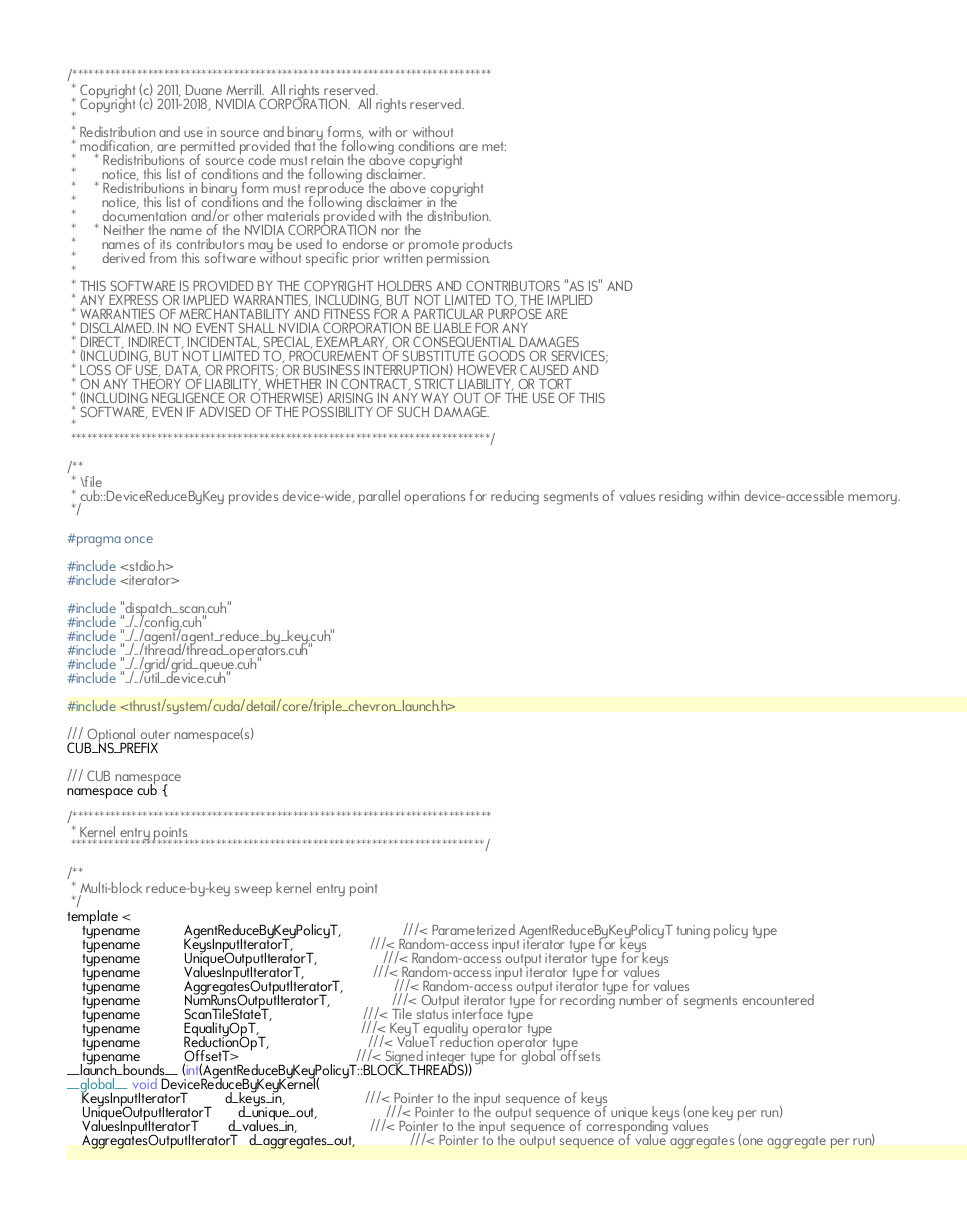Convert code to text. <code><loc_0><loc_0><loc_500><loc_500><_Cuda_>
/******************************************************************************
 * Copyright (c) 2011, Duane Merrill.  All rights reserved.
 * Copyright (c) 2011-2018, NVIDIA CORPORATION.  All rights reserved.
 *
 * Redistribution and use in source and binary forms, with or without
 * modification, are permitted provided that the following conditions are met:
 *     * Redistributions of source code must retain the above copyright
 *       notice, this list of conditions and the following disclaimer.
 *     * Redistributions in binary form must reproduce the above copyright
 *       notice, this list of conditions and the following disclaimer in the
 *       documentation and/or other materials provided with the distribution.
 *     * Neither the name of the NVIDIA CORPORATION nor the
 *       names of its contributors may be used to endorse or promote products
 *       derived from this software without specific prior written permission.
 *
 * THIS SOFTWARE IS PROVIDED BY THE COPYRIGHT HOLDERS AND CONTRIBUTORS "AS IS" AND
 * ANY EXPRESS OR IMPLIED WARRANTIES, INCLUDING, BUT NOT LIMITED TO, THE IMPLIED
 * WARRANTIES OF MERCHANTABILITY AND FITNESS FOR A PARTICULAR PURPOSE ARE
 * DISCLAIMED. IN NO EVENT SHALL NVIDIA CORPORATION BE LIABLE FOR ANY
 * DIRECT, INDIRECT, INCIDENTAL, SPECIAL, EXEMPLARY, OR CONSEQUENTIAL DAMAGES
 * (INCLUDING, BUT NOT LIMITED TO, PROCUREMENT OF SUBSTITUTE GOODS OR SERVICES;
 * LOSS OF USE, DATA, OR PROFITS; OR BUSINESS INTERRUPTION) HOWEVER CAUSED AND
 * ON ANY THEORY OF LIABILITY, WHETHER IN CONTRACT, STRICT LIABILITY, OR TORT
 * (INCLUDING NEGLIGENCE OR OTHERWISE) ARISING IN ANY WAY OUT OF THE USE OF THIS
 * SOFTWARE, EVEN IF ADVISED OF THE POSSIBILITY OF SUCH DAMAGE.
 *
 ******************************************************************************/

/**
 * \file
 * cub::DeviceReduceByKey provides device-wide, parallel operations for reducing segments of values residing within device-accessible memory.
 */

#pragma once

#include <stdio.h>
#include <iterator>

#include "dispatch_scan.cuh"
#include "../../config.cuh"
#include "../../agent/agent_reduce_by_key.cuh"
#include "../../thread/thread_operators.cuh"
#include "../../grid/grid_queue.cuh"
#include "../../util_device.cuh"

#include <thrust/system/cuda/detail/core/triple_chevron_launch.h>

/// Optional outer namespace(s)
CUB_NS_PREFIX

/// CUB namespace
namespace cub {

/******************************************************************************
 * Kernel entry points
 *****************************************************************************/

/**
 * Multi-block reduce-by-key sweep kernel entry point
 */
template <
    typename            AgentReduceByKeyPolicyT,                 ///< Parameterized AgentReduceByKeyPolicyT tuning policy type
    typename            KeysInputIteratorT,                     ///< Random-access input iterator type for keys
    typename            UniqueOutputIteratorT,                  ///< Random-access output iterator type for keys
    typename            ValuesInputIteratorT,                   ///< Random-access input iterator type for values
    typename            AggregatesOutputIteratorT,              ///< Random-access output iterator type for values
    typename            NumRunsOutputIteratorT,                 ///< Output iterator type for recording number of segments encountered
    typename            ScanTileStateT,                         ///< Tile status interface type
    typename            EqualityOpT,                            ///< KeyT equality operator type
    typename            ReductionOpT,                           ///< ValueT reduction operator type
    typename            OffsetT>                                ///< Signed integer type for global offsets
__launch_bounds__ (int(AgentReduceByKeyPolicyT::BLOCK_THREADS))
__global__ void DeviceReduceByKeyKernel(
    KeysInputIteratorT          d_keys_in,                      ///< Pointer to the input sequence of keys
    UniqueOutputIteratorT       d_unique_out,                   ///< Pointer to the output sequence of unique keys (one key per run)
    ValuesInputIteratorT        d_values_in,                    ///< Pointer to the input sequence of corresponding values
    AggregatesOutputIteratorT   d_aggregates_out,               ///< Pointer to the output sequence of value aggregates (one aggregate per run)</code> 